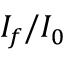Convert formula to latex. <formula><loc_0><loc_0><loc_500><loc_500>I _ { f } / I _ { 0 }</formula> 